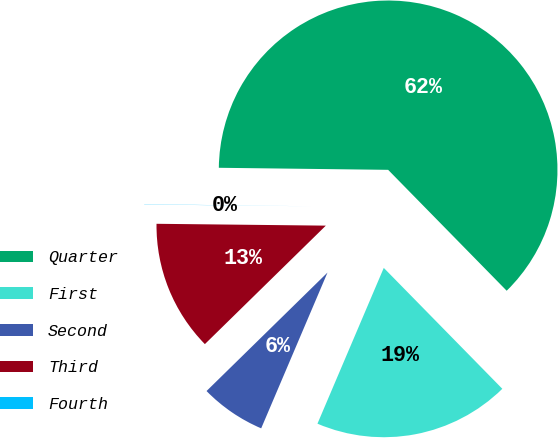<chart> <loc_0><loc_0><loc_500><loc_500><pie_chart><fcel>Quarter<fcel>First<fcel>Second<fcel>Third<fcel>Fourth<nl><fcel>62.47%<fcel>18.75%<fcel>6.26%<fcel>12.51%<fcel>0.02%<nl></chart> 